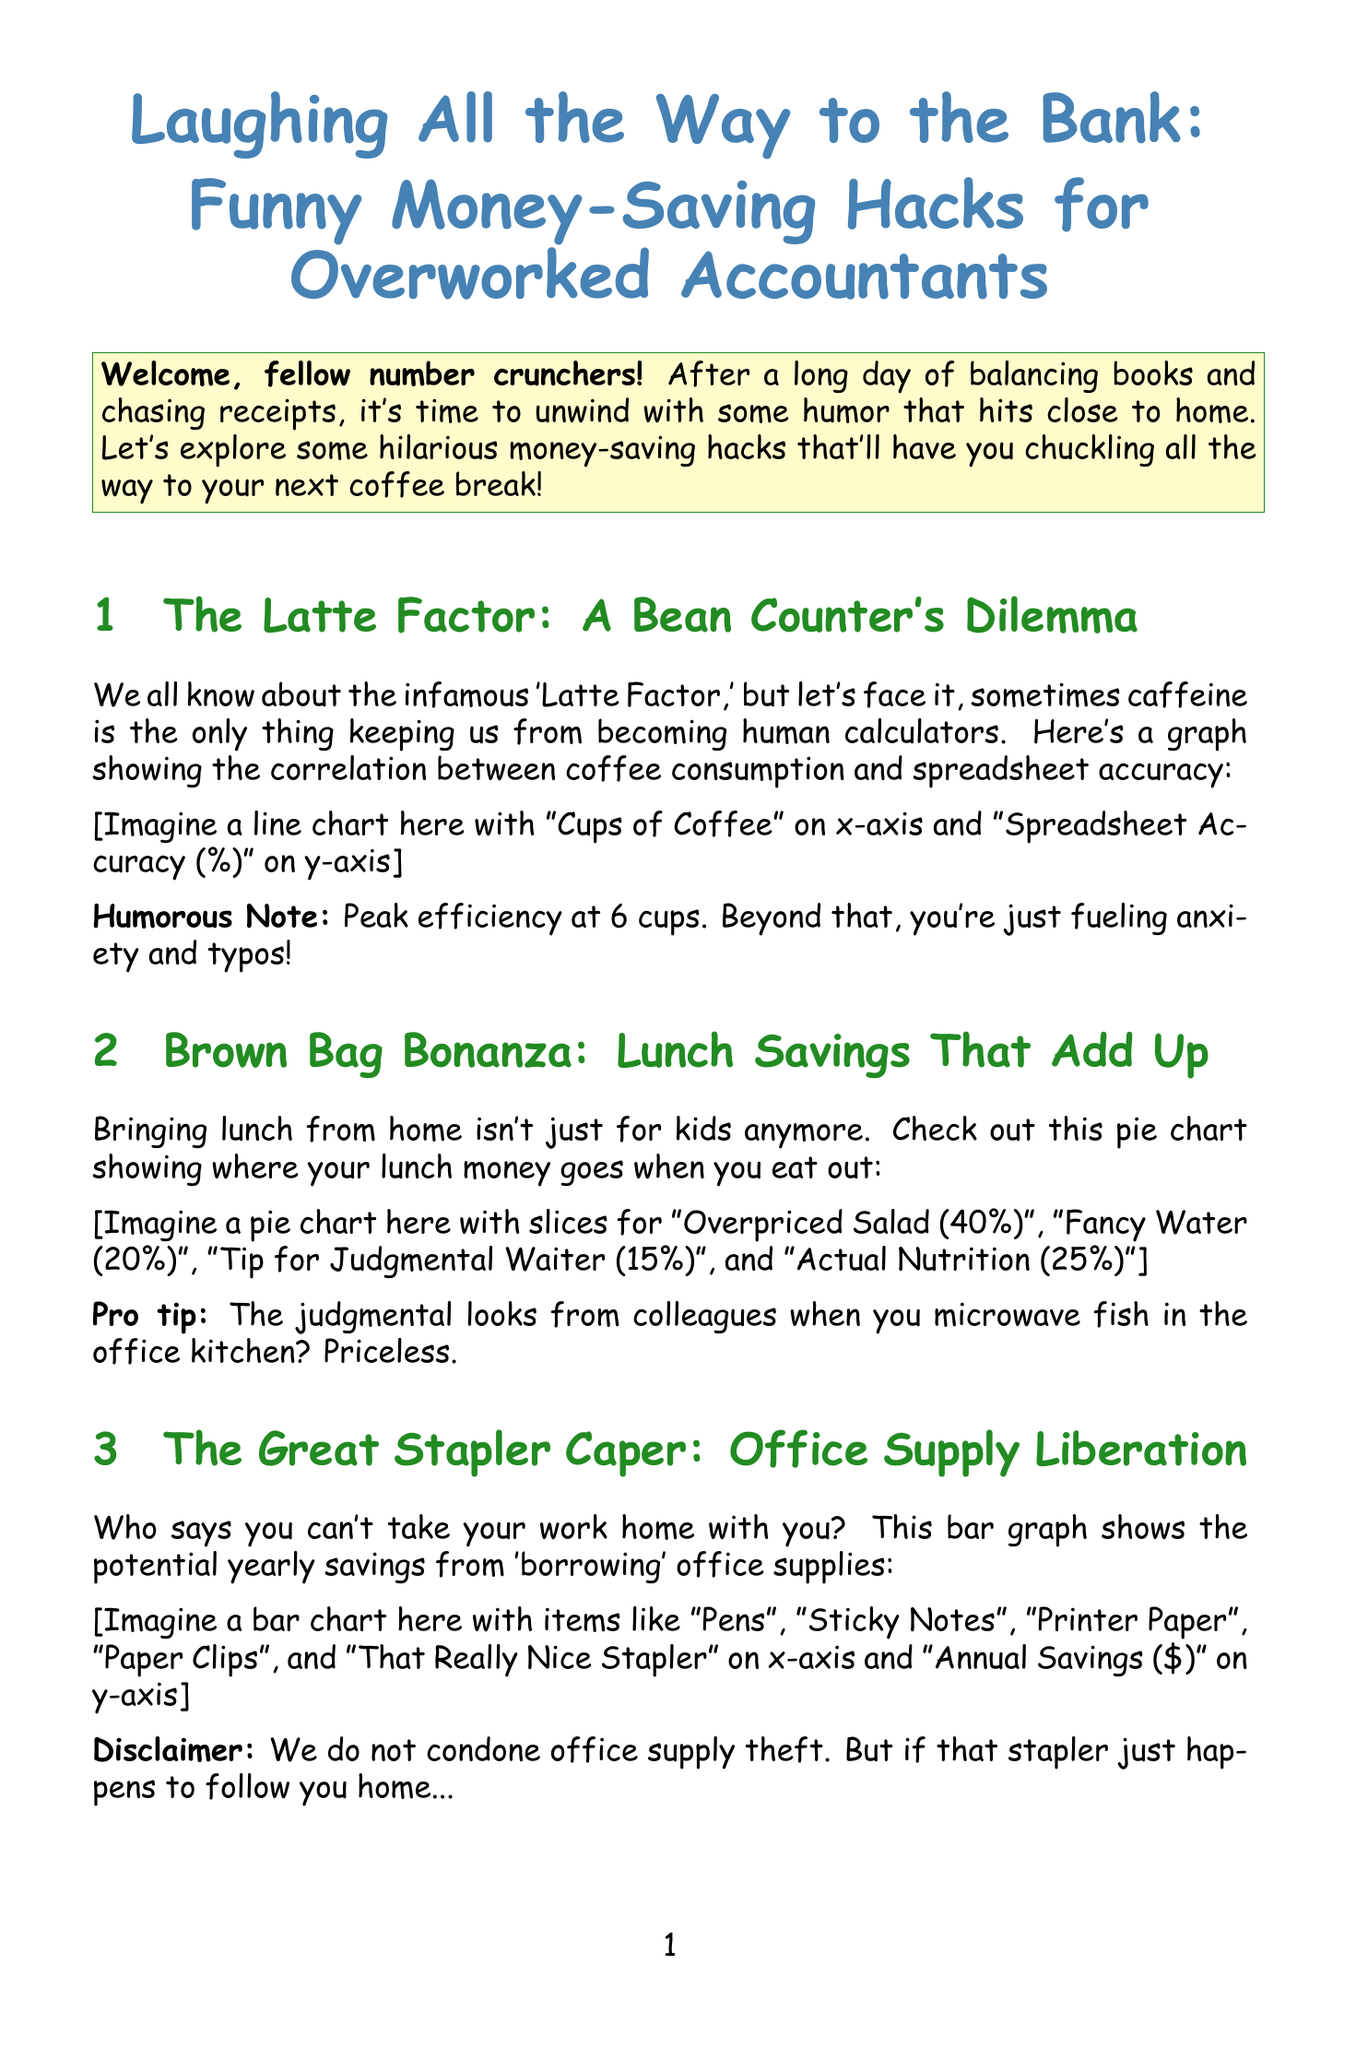What is the title of the newsletter? The title is presented prominently at the beginning of the document.
Answer: Laughing All the Way to the Bank: Funny Money-Saving Hacks for Overworked Accountants What humorous note accompanies the coffee graph? The humorous note provides a lighthearted observation about coffee consumption and spreadsheet accuracy.
Answer: Peak efficiency at 6 cups. Beyond that, you're just fueling anxiety and typos! What is the percentage of lunch money spent on "Overpriced Salad"? The pie chart provides specific percentages for different categories of lunch expenses.
Answer: 40 What item has the highest annual savings from 'borrowing' office supplies? The bar graph lists savings from various supplies, highlighting the one with the highest value.
Answer: Printer Paper What is the enjoyment level of watching paint dry? The scatter plot includes a specific enjoyment level for this activity.
Answer: 1 How many cups of coffee correspond to 99% spreadsheet accuracy? The line chart shows the relationship between coffee consumption and accuracy, indicating a specific number of cups.
Answer: 6 What is the humorous note related to microwaving fish? The document provides a funny remark about a common office scenario involving food.
Answer: The judgmental looks from colleagues when you microwave fish in the office kitchen? Priceless What is the main takeaway from the conclusion section? The conclusion summarizes the overarching theme of the newsletter and its message.
Answer: Laughter is the best medicine—and it's tax-free! 